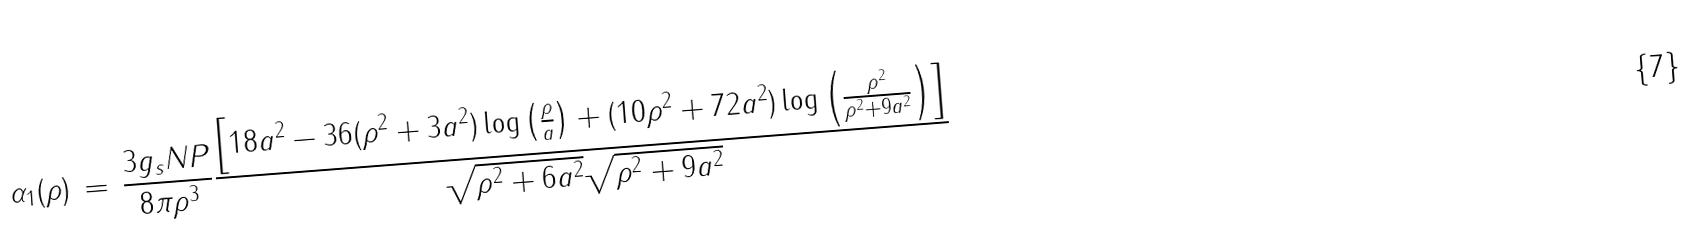<formula> <loc_0><loc_0><loc_500><loc_500>\alpha _ { 1 } ( \rho ) \, = \, \frac { 3 g _ { s } N P } { 8 \pi \rho ^ { 3 } } \frac { \left [ 1 8 a ^ { 2 } - 3 6 ( \rho ^ { 2 } + 3 a ^ { 2 } ) \log \left ( \frac { \rho } { a } \right ) + ( 1 0 \rho ^ { 2 } + 7 2 a ^ { 2 } ) \log \left ( \frac { \rho ^ { 2 } } { \rho ^ { 2 } + 9 a ^ { 2 } } \right ) \right ] } { \sqrt { \rho ^ { 2 } + 6 a ^ { 2 } } \sqrt { \rho ^ { 2 } + 9 a ^ { 2 } } }</formula> 